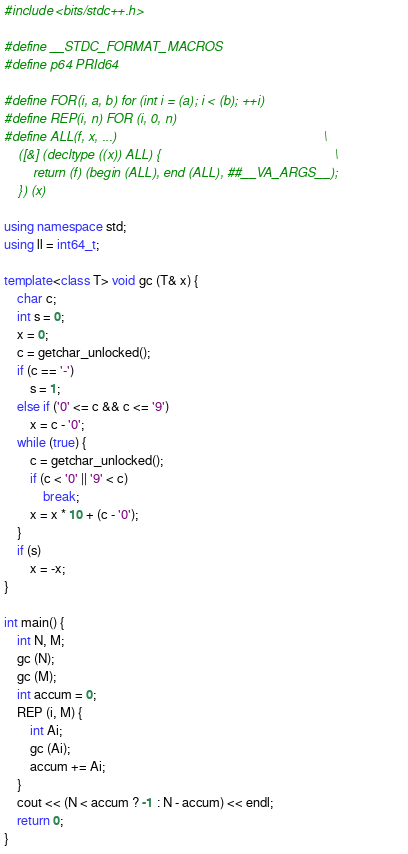<code> <loc_0><loc_0><loc_500><loc_500><_C++_>#include <bits/stdc++.h>

#define __STDC_FORMAT_MACROS
#define p64 PRId64

#define FOR(i, a, b) for (int i = (a); i < (b); ++i)
#define REP(i, n) FOR (i, 0, n)
#define ALL(f, x, ...)                                                         \
    ([&] (decltype ((x)) ALL) {                                                \
        return (f) (begin (ALL), end (ALL), ##__VA_ARGS__);                    \
    }) (x)

using namespace std;
using ll = int64_t;

template<class T> void gc (T& x) {
    char c;
    int s = 0;
    x = 0;
    c = getchar_unlocked();
    if (c == '-')
        s = 1;
    else if ('0' <= c && c <= '9')
        x = c - '0';
    while (true) {
        c = getchar_unlocked();
        if (c < '0' || '9' < c)
            break;
        x = x * 10 + (c - '0');
    }
    if (s)
        x = -x;
}

int main() {
    int N, M;
    gc (N);
    gc (M);
    int accum = 0;
    REP (i, M) {
        int Ai;
        gc (Ai);
        accum += Ai;
    }
    cout << (N < accum ? -1 : N - accum) << endl;
    return 0;
}
</code> 